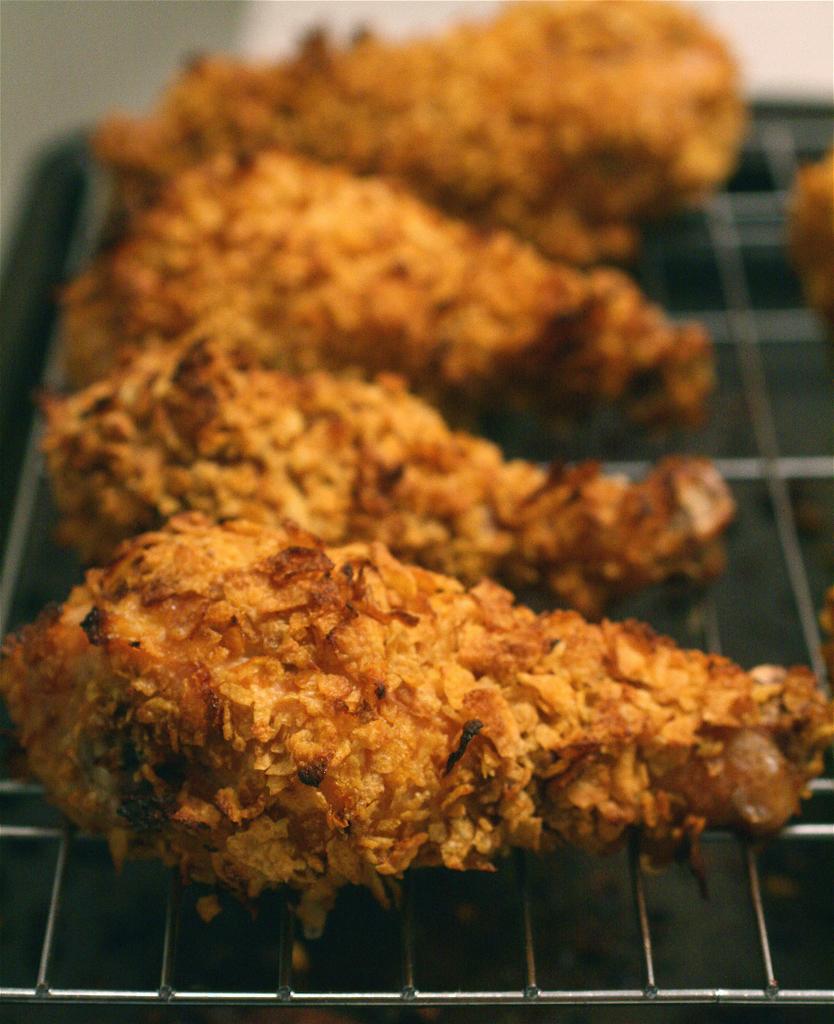Please provide a concise description of this image. In this image we can see some food item on the grille, and the background is blurred. 